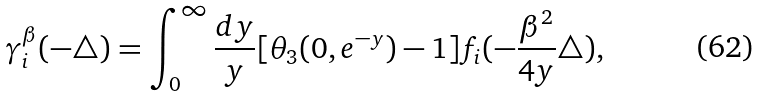<formula> <loc_0><loc_0><loc_500><loc_500>\gamma _ { i } ^ { \beta } ( - \triangle ) = \int _ { 0 } ^ { \infty } \frac { d y } { y } [ \theta _ { 3 } ( 0 , e ^ { - y } ) - 1 ] f _ { i } ( - \frac { \beta ^ { 2 } } { 4 y } \triangle ) ,</formula> 